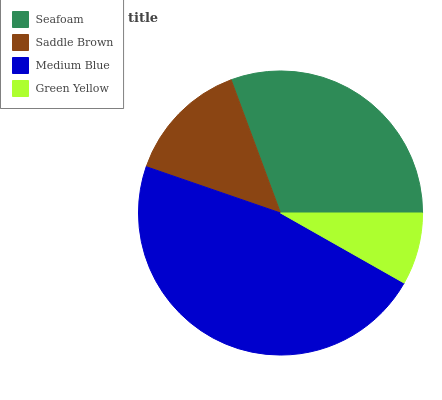Is Green Yellow the minimum?
Answer yes or no. Yes. Is Medium Blue the maximum?
Answer yes or no. Yes. Is Saddle Brown the minimum?
Answer yes or no. No. Is Saddle Brown the maximum?
Answer yes or no. No. Is Seafoam greater than Saddle Brown?
Answer yes or no. Yes. Is Saddle Brown less than Seafoam?
Answer yes or no. Yes. Is Saddle Brown greater than Seafoam?
Answer yes or no. No. Is Seafoam less than Saddle Brown?
Answer yes or no. No. Is Seafoam the high median?
Answer yes or no. Yes. Is Saddle Brown the low median?
Answer yes or no. Yes. Is Saddle Brown the high median?
Answer yes or no. No. Is Seafoam the low median?
Answer yes or no. No. 